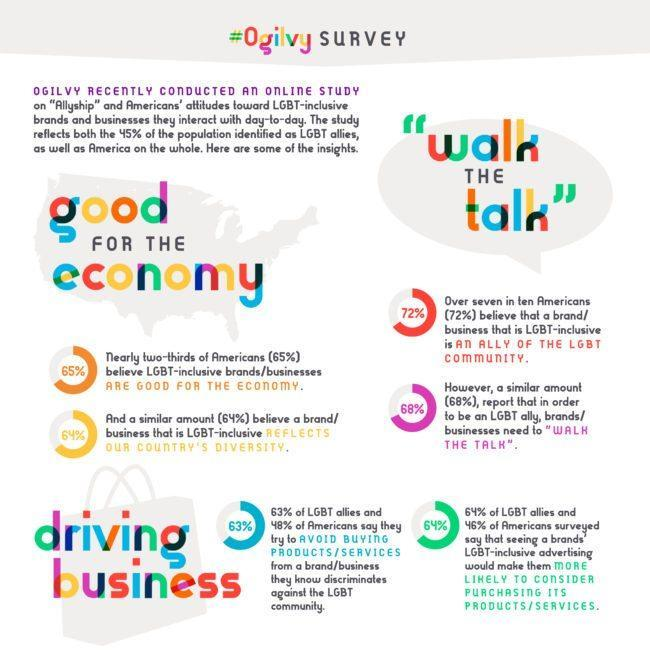What percentage of Americans are more interested to buy products, services from a brand which are promoted by LGBT community?
Answer the question with a short phrase. 46% What percentage of LGBT allies are interested to buy products, services from a brand which are promoted by LGBT community? 64% What percentage of Americans are not interested to buy products, services from a brand which discriminates LGBT community? 48% What percentage of Americans do not believe LGBT inclusive brands are good for the economy? 35 What percentage of LGBT allies do not buy products, services from a brand which discriminates LGBT community? 63% 